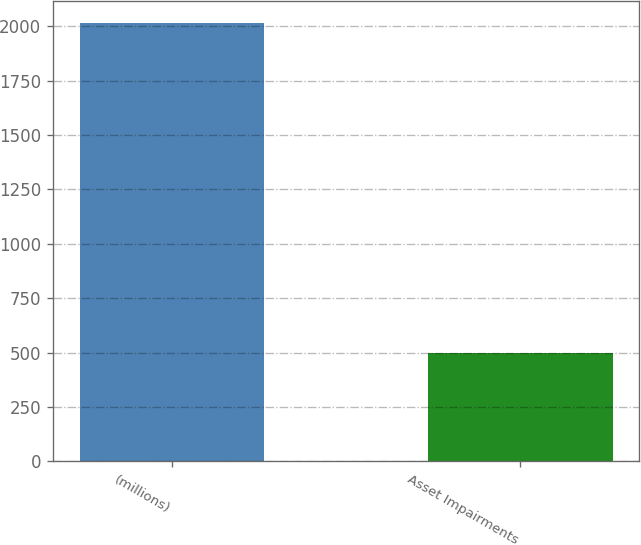Convert chart to OTSL. <chart><loc_0><loc_0><loc_500><loc_500><bar_chart><fcel>(millions)<fcel>Asset Impairments<nl><fcel>2014<fcel>500<nl></chart> 